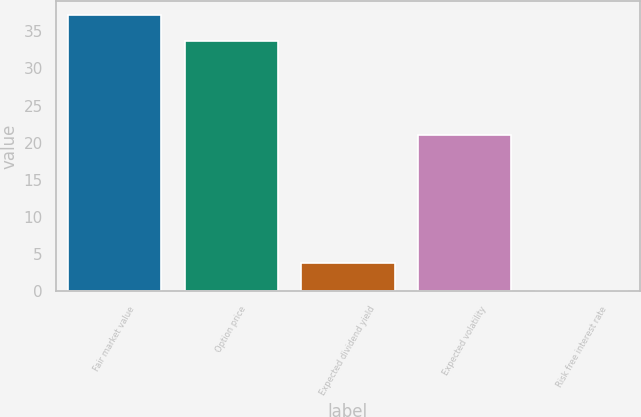<chart> <loc_0><loc_0><loc_500><loc_500><bar_chart><fcel>Fair market value<fcel>Option price<fcel>Expected dividend yield<fcel>Expected volatility<fcel>Risk free interest rate<nl><fcel>37.2<fcel>33.66<fcel>3.83<fcel>21<fcel>0.07<nl></chart> 